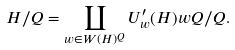Convert formula to latex. <formula><loc_0><loc_0><loc_500><loc_500>H / Q = \coprod _ { w \in W ( H ) ^ { Q } } U ^ { \prime } _ { w } ( H ) w Q / Q .</formula> 